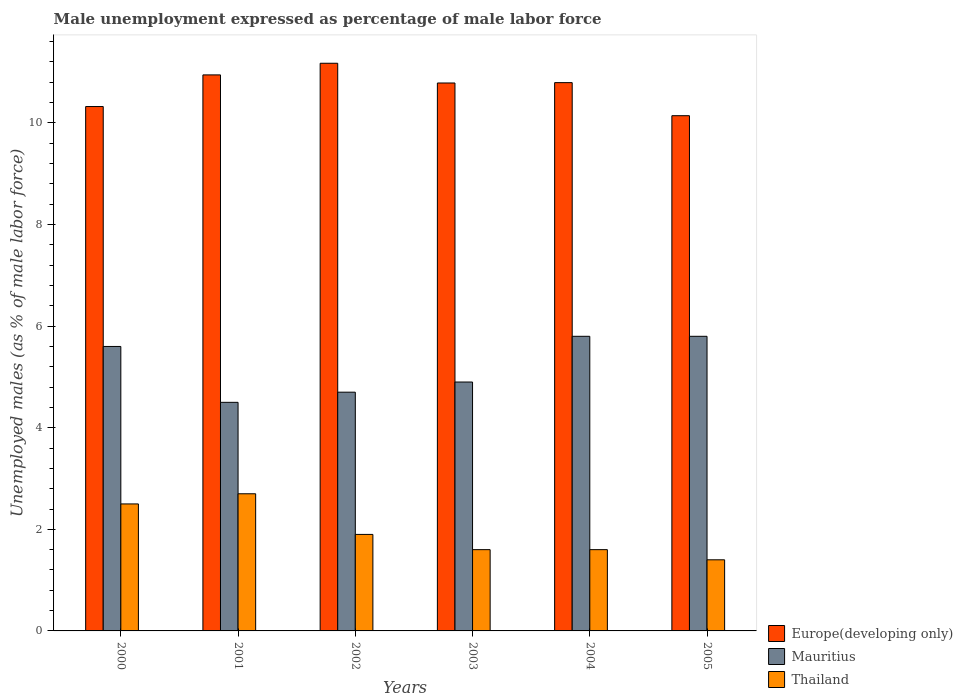Are the number of bars per tick equal to the number of legend labels?
Your response must be concise. Yes. How many bars are there on the 1st tick from the left?
Make the answer very short. 3. What is the label of the 4th group of bars from the left?
Make the answer very short. 2003. In how many cases, is the number of bars for a given year not equal to the number of legend labels?
Provide a succinct answer. 0. What is the unemployment in males in in Thailand in 2003?
Your answer should be very brief. 1.6. Across all years, what is the maximum unemployment in males in in Thailand?
Offer a terse response. 2.7. Across all years, what is the minimum unemployment in males in in Mauritius?
Give a very brief answer. 4.5. In which year was the unemployment in males in in Mauritius minimum?
Your answer should be very brief. 2001. What is the total unemployment in males in in Europe(developing only) in the graph?
Provide a succinct answer. 64.17. What is the difference between the unemployment in males in in Thailand in 2003 and that in 2005?
Offer a very short reply. 0.2. What is the difference between the unemployment in males in in Mauritius in 2003 and the unemployment in males in in Thailand in 2001?
Your answer should be very brief. 2.2. What is the average unemployment in males in in Europe(developing only) per year?
Provide a short and direct response. 10.69. In the year 2003, what is the difference between the unemployment in males in in Thailand and unemployment in males in in Europe(developing only)?
Offer a very short reply. -9.19. What is the ratio of the unemployment in males in in Thailand in 2001 to that in 2003?
Provide a short and direct response. 1.69. Is the unemployment in males in in Europe(developing only) in 2000 less than that in 2003?
Offer a very short reply. Yes. What is the difference between the highest and the second highest unemployment in males in in Mauritius?
Offer a terse response. 0. What is the difference between the highest and the lowest unemployment in males in in Thailand?
Provide a short and direct response. 1.3. In how many years, is the unemployment in males in in Europe(developing only) greater than the average unemployment in males in in Europe(developing only) taken over all years?
Offer a terse response. 4. What does the 1st bar from the left in 2001 represents?
Make the answer very short. Europe(developing only). What does the 3rd bar from the right in 2002 represents?
Offer a very short reply. Europe(developing only). Does the graph contain grids?
Offer a terse response. No. How are the legend labels stacked?
Provide a short and direct response. Vertical. What is the title of the graph?
Keep it short and to the point. Male unemployment expressed as percentage of male labor force. Does "Arab World" appear as one of the legend labels in the graph?
Your response must be concise. No. What is the label or title of the Y-axis?
Your answer should be very brief. Unemployed males (as % of male labor force). What is the Unemployed males (as % of male labor force) of Europe(developing only) in 2000?
Offer a very short reply. 10.32. What is the Unemployed males (as % of male labor force) in Mauritius in 2000?
Make the answer very short. 5.6. What is the Unemployed males (as % of male labor force) of Thailand in 2000?
Your response must be concise. 2.5. What is the Unemployed males (as % of male labor force) of Europe(developing only) in 2001?
Provide a succinct answer. 10.95. What is the Unemployed males (as % of male labor force) in Thailand in 2001?
Offer a very short reply. 2.7. What is the Unemployed males (as % of male labor force) of Europe(developing only) in 2002?
Your response must be concise. 11.18. What is the Unemployed males (as % of male labor force) of Mauritius in 2002?
Make the answer very short. 4.7. What is the Unemployed males (as % of male labor force) of Thailand in 2002?
Your answer should be compact. 1.9. What is the Unemployed males (as % of male labor force) of Europe(developing only) in 2003?
Your answer should be compact. 10.79. What is the Unemployed males (as % of male labor force) in Mauritius in 2003?
Your answer should be compact. 4.9. What is the Unemployed males (as % of male labor force) in Thailand in 2003?
Provide a short and direct response. 1.6. What is the Unemployed males (as % of male labor force) in Europe(developing only) in 2004?
Provide a short and direct response. 10.79. What is the Unemployed males (as % of male labor force) in Mauritius in 2004?
Keep it short and to the point. 5.8. What is the Unemployed males (as % of male labor force) in Thailand in 2004?
Offer a terse response. 1.6. What is the Unemployed males (as % of male labor force) in Europe(developing only) in 2005?
Provide a short and direct response. 10.14. What is the Unemployed males (as % of male labor force) in Mauritius in 2005?
Make the answer very short. 5.8. What is the Unemployed males (as % of male labor force) in Thailand in 2005?
Ensure brevity in your answer.  1.4. Across all years, what is the maximum Unemployed males (as % of male labor force) of Europe(developing only)?
Give a very brief answer. 11.18. Across all years, what is the maximum Unemployed males (as % of male labor force) of Mauritius?
Your response must be concise. 5.8. Across all years, what is the maximum Unemployed males (as % of male labor force) of Thailand?
Your answer should be very brief. 2.7. Across all years, what is the minimum Unemployed males (as % of male labor force) in Europe(developing only)?
Give a very brief answer. 10.14. Across all years, what is the minimum Unemployed males (as % of male labor force) in Mauritius?
Provide a succinct answer. 4.5. Across all years, what is the minimum Unemployed males (as % of male labor force) in Thailand?
Your response must be concise. 1.4. What is the total Unemployed males (as % of male labor force) in Europe(developing only) in the graph?
Give a very brief answer. 64.17. What is the total Unemployed males (as % of male labor force) in Mauritius in the graph?
Give a very brief answer. 31.3. What is the total Unemployed males (as % of male labor force) in Thailand in the graph?
Offer a terse response. 11.7. What is the difference between the Unemployed males (as % of male labor force) in Europe(developing only) in 2000 and that in 2001?
Offer a very short reply. -0.62. What is the difference between the Unemployed males (as % of male labor force) of Thailand in 2000 and that in 2001?
Your response must be concise. -0.2. What is the difference between the Unemployed males (as % of male labor force) in Europe(developing only) in 2000 and that in 2002?
Ensure brevity in your answer.  -0.85. What is the difference between the Unemployed males (as % of male labor force) in Mauritius in 2000 and that in 2002?
Your answer should be very brief. 0.9. What is the difference between the Unemployed males (as % of male labor force) in Thailand in 2000 and that in 2002?
Provide a succinct answer. 0.6. What is the difference between the Unemployed males (as % of male labor force) of Europe(developing only) in 2000 and that in 2003?
Provide a short and direct response. -0.46. What is the difference between the Unemployed males (as % of male labor force) of Mauritius in 2000 and that in 2003?
Your answer should be compact. 0.7. What is the difference between the Unemployed males (as % of male labor force) in Europe(developing only) in 2000 and that in 2004?
Keep it short and to the point. -0.47. What is the difference between the Unemployed males (as % of male labor force) of Mauritius in 2000 and that in 2004?
Make the answer very short. -0.2. What is the difference between the Unemployed males (as % of male labor force) in Europe(developing only) in 2000 and that in 2005?
Your answer should be very brief. 0.18. What is the difference between the Unemployed males (as % of male labor force) of Thailand in 2000 and that in 2005?
Offer a very short reply. 1.1. What is the difference between the Unemployed males (as % of male labor force) in Europe(developing only) in 2001 and that in 2002?
Give a very brief answer. -0.23. What is the difference between the Unemployed males (as % of male labor force) of Thailand in 2001 and that in 2002?
Offer a terse response. 0.8. What is the difference between the Unemployed males (as % of male labor force) of Europe(developing only) in 2001 and that in 2003?
Your answer should be compact. 0.16. What is the difference between the Unemployed males (as % of male labor force) of Thailand in 2001 and that in 2003?
Give a very brief answer. 1.1. What is the difference between the Unemployed males (as % of male labor force) in Europe(developing only) in 2001 and that in 2004?
Your response must be concise. 0.15. What is the difference between the Unemployed males (as % of male labor force) of Europe(developing only) in 2001 and that in 2005?
Provide a short and direct response. 0.8. What is the difference between the Unemployed males (as % of male labor force) of Thailand in 2001 and that in 2005?
Your answer should be very brief. 1.3. What is the difference between the Unemployed males (as % of male labor force) in Europe(developing only) in 2002 and that in 2003?
Your response must be concise. 0.39. What is the difference between the Unemployed males (as % of male labor force) of Mauritius in 2002 and that in 2003?
Give a very brief answer. -0.2. What is the difference between the Unemployed males (as % of male labor force) of Thailand in 2002 and that in 2003?
Give a very brief answer. 0.3. What is the difference between the Unemployed males (as % of male labor force) of Europe(developing only) in 2002 and that in 2004?
Your answer should be compact. 0.38. What is the difference between the Unemployed males (as % of male labor force) in Mauritius in 2002 and that in 2004?
Offer a very short reply. -1.1. What is the difference between the Unemployed males (as % of male labor force) of Thailand in 2002 and that in 2004?
Your answer should be very brief. 0.3. What is the difference between the Unemployed males (as % of male labor force) of Europe(developing only) in 2002 and that in 2005?
Ensure brevity in your answer.  1.03. What is the difference between the Unemployed males (as % of male labor force) of Thailand in 2002 and that in 2005?
Your answer should be very brief. 0.5. What is the difference between the Unemployed males (as % of male labor force) of Europe(developing only) in 2003 and that in 2004?
Your answer should be very brief. -0.01. What is the difference between the Unemployed males (as % of male labor force) in Thailand in 2003 and that in 2004?
Your answer should be compact. 0. What is the difference between the Unemployed males (as % of male labor force) of Europe(developing only) in 2003 and that in 2005?
Give a very brief answer. 0.64. What is the difference between the Unemployed males (as % of male labor force) in Europe(developing only) in 2004 and that in 2005?
Provide a succinct answer. 0.65. What is the difference between the Unemployed males (as % of male labor force) of Mauritius in 2004 and that in 2005?
Provide a succinct answer. 0. What is the difference between the Unemployed males (as % of male labor force) in Thailand in 2004 and that in 2005?
Provide a succinct answer. 0.2. What is the difference between the Unemployed males (as % of male labor force) of Europe(developing only) in 2000 and the Unemployed males (as % of male labor force) of Mauritius in 2001?
Offer a terse response. 5.82. What is the difference between the Unemployed males (as % of male labor force) of Europe(developing only) in 2000 and the Unemployed males (as % of male labor force) of Thailand in 2001?
Give a very brief answer. 7.62. What is the difference between the Unemployed males (as % of male labor force) in Mauritius in 2000 and the Unemployed males (as % of male labor force) in Thailand in 2001?
Keep it short and to the point. 2.9. What is the difference between the Unemployed males (as % of male labor force) in Europe(developing only) in 2000 and the Unemployed males (as % of male labor force) in Mauritius in 2002?
Keep it short and to the point. 5.62. What is the difference between the Unemployed males (as % of male labor force) of Europe(developing only) in 2000 and the Unemployed males (as % of male labor force) of Thailand in 2002?
Give a very brief answer. 8.42. What is the difference between the Unemployed males (as % of male labor force) of Europe(developing only) in 2000 and the Unemployed males (as % of male labor force) of Mauritius in 2003?
Provide a succinct answer. 5.42. What is the difference between the Unemployed males (as % of male labor force) of Europe(developing only) in 2000 and the Unemployed males (as % of male labor force) of Thailand in 2003?
Ensure brevity in your answer.  8.72. What is the difference between the Unemployed males (as % of male labor force) of Mauritius in 2000 and the Unemployed males (as % of male labor force) of Thailand in 2003?
Your answer should be very brief. 4. What is the difference between the Unemployed males (as % of male labor force) in Europe(developing only) in 2000 and the Unemployed males (as % of male labor force) in Mauritius in 2004?
Make the answer very short. 4.52. What is the difference between the Unemployed males (as % of male labor force) of Europe(developing only) in 2000 and the Unemployed males (as % of male labor force) of Thailand in 2004?
Your response must be concise. 8.72. What is the difference between the Unemployed males (as % of male labor force) of Europe(developing only) in 2000 and the Unemployed males (as % of male labor force) of Mauritius in 2005?
Provide a succinct answer. 4.52. What is the difference between the Unemployed males (as % of male labor force) of Europe(developing only) in 2000 and the Unemployed males (as % of male labor force) of Thailand in 2005?
Keep it short and to the point. 8.92. What is the difference between the Unemployed males (as % of male labor force) in Europe(developing only) in 2001 and the Unemployed males (as % of male labor force) in Mauritius in 2002?
Provide a short and direct response. 6.25. What is the difference between the Unemployed males (as % of male labor force) in Europe(developing only) in 2001 and the Unemployed males (as % of male labor force) in Thailand in 2002?
Provide a succinct answer. 9.05. What is the difference between the Unemployed males (as % of male labor force) of Mauritius in 2001 and the Unemployed males (as % of male labor force) of Thailand in 2002?
Offer a terse response. 2.6. What is the difference between the Unemployed males (as % of male labor force) in Europe(developing only) in 2001 and the Unemployed males (as % of male labor force) in Mauritius in 2003?
Provide a succinct answer. 6.05. What is the difference between the Unemployed males (as % of male labor force) in Europe(developing only) in 2001 and the Unemployed males (as % of male labor force) in Thailand in 2003?
Ensure brevity in your answer.  9.35. What is the difference between the Unemployed males (as % of male labor force) in Mauritius in 2001 and the Unemployed males (as % of male labor force) in Thailand in 2003?
Ensure brevity in your answer.  2.9. What is the difference between the Unemployed males (as % of male labor force) of Europe(developing only) in 2001 and the Unemployed males (as % of male labor force) of Mauritius in 2004?
Offer a terse response. 5.15. What is the difference between the Unemployed males (as % of male labor force) of Europe(developing only) in 2001 and the Unemployed males (as % of male labor force) of Thailand in 2004?
Your answer should be compact. 9.35. What is the difference between the Unemployed males (as % of male labor force) in Mauritius in 2001 and the Unemployed males (as % of male labor force) in Thailand in 2004?
Keep it short and to the point. 2.9. What is the difference between the Unemployed males (as % of male labor force) of Europe(developing only) in 2001 and the Unemployed males (as % of male labor force) of Mauritius in 2005?
Offer a very short reply. 5.15. What is the difference between the Unemployed males (as % of male labor force) of Europe(developing only) in 2001 and the Unemployed males (as % of male labor force) of Thailand in 2005?
Your response must be concise. 9.55. What is the difference between the Unemployed males (as % of male labor force) in Mauritius in 2001 and the Unemployed males (as % of male labor force) in Thailand in 2005?
Provide a succinct answer. 3.1. What is the difference between the Unemployed males (as % of male labor force) of Europe(developing only) in 2002 and the Unemployed males (as % of male labor force) of Mauritius in 2003?
Provide a succinct answer. 6.28. What is the difference between the Unemployed males (as % of male labor force) of Europe(developing only) in 2002 and the Unemployed males (as % of male labor force) of Thailand in 2003?
Keep it short and to the point. 9.58. What is the difference between the Unemployed males (as % of male labor force) in Mauritius in 2002 and the Unemployed males (as % of male labor force) in Thailand in 2003?
Your response must be concise. 3.1. What is the difference between the Unemployed males (as % of male labor force) of Europe(developing only) in 2002 and the Unemployed males (as % of male labor force) of Mauritius in 2004?
Offer a very short reply. 5.38. What is the difference between the Unemployed males (as % of male labor force) of Europe(developing only) in 2002 and the Unemployed males (as % of male labor force) of Thailand in 2004?
Offer a very short reply. 9.58. What is the difference between the Unemployed males (as % of male labor force) of Mauritius in 2002 and the Unemployed males (as % of male labor force) of Thailand in 2004?
Make the answer very short. 3.1. What is the difference between the Unemployed males (as % of male labor force) in Europe(developing only) in 2002 and the Unemployed males (as % of male labor force) in Mauritius in 2005?
Your answer should be compact. 5.38. What is the difference between the Unemployed males (as % of male labor force) of Europe(developing only) in 2002 and the Unemployed males (as % of male labor force) of Thailand in 2005?
Provide a succinct answer. 9.78. What is the difference between the Unemployed males (as % of male labor force) in Mauritius in 2002 and the Unemployed males (as % of male labor force) in Thailand in 2005?
Your answer should be very brief. 3.3. What is the difference between the Unemployed males (as % of male labor force) in Europe(developing only) in 2003 and the Unemployed males (as % of male labor force) in Mauritius in 2004?
Provide a succinct answer. 4.99. What is the difference between the Unemployed males (as % of male labor force) of Europe(developing only) in 2003 and the Unemployed males (as % of male labor force) of Thailand in 2004?
Your response must be concise. 9.19. What is the difference between the Unemployed males (as % of male labor force) in Mauritius in 2003 and the Unemployed males (as % of male labor force) in Thailand in 2004?
Your answer should be compact. 3.3. What is the difference between the Unemployed males (as % of male labor force) in Europe(developing only) in 2003 and the Unemployed males (as % of male labor force) in Mauritius in 2005?
Your response must be concise. 4.99. What is the difference between the Unemployed males (as % of male labor force) in Europe(developing only) in 2003 and the Unemployed males (as % of male labor force) in Thailand in 2005?
Keep it short and to the point. 9.39. What is the difference between the Unemployed males (as % of male labor force) of Mauritius in 2003 and the Unemployed males (as % of male labor force) of Thailand in 2005?
Provide a short and direct response. 3.5. What is the difference between the Unemployed males (as % of male labor force) in Europe(developing only) in 2004 and the Unemployed males (as % of male labor force) in Mauritius in 2005?
Your response must be concise. 4.99. What is the difference between the Unemployed males (as % of male labor force) in Europe(developing only) in 2004 and the Unemployed males (as % of male labor force) in Thailand in 2005?
Make the answer very short. 9.39. What is the difference between the Unemployed males (as % of male labor force) in Mauritius in 2004 and the Unemployed males (as % of male labor force) in Thailand in 2005?
Provide a short and direct response. 4.4. What is the average Unemployed males (as % of male labor force) of Europe(developing only) per year?
Ensure brevity in your answer.  10.69. What is the average Unemployed males (as % of male labor force) of Mauritius per year?
Ensure brevity in your answer.  5.22. What is the average Unemployed males (as % of male labor force) in Thailand per year?
Provide a short and direct response. 1.95. In the year 2000, what is the difference between the Unemployed males (as % of male labor force) of Europe(developing only) and Unemployed males (as % of male labor force) of Mauritius?
Provide a succinct answer. 4.72. In the year 2000, what is the difference between the Unemployed males (as % of male labor force) in Europe(developing only) and Unemployed males (as % of male labor force) in Thailand?
Ensure brevity in your answer.  7.82. In the year 2001, what is the difference between the Unemployed males (as % of male labor force) of Europe(developing only) and Unemployed males (as % of male labor force) of Mauritius?
Give a very brief answer. 6.45. In the year 2001, what is the difference between the Unemployed males (as % of male labor force) of Europe(developing only) and Unemployed males (as % of male labor force) of Thailand?
Offer a very short reply. 8.25. In the year 2001, what is the difference between the Unemployed males (as % of male labor force) of Mauritius and Unemployed males (as % of male labor force) of Thailand?
Your answer should be compact. 1.8. In the year 2002, what is the difference between the Unemployed males (as % of male labor force) of Europe(developing only) and Unemployed males (as % of male labor force) of Mauritius?
Give a very brief answer. 6.48. In the year 2002, what is the difference between the Unemployed males (as % of male labor force) in Europe(developing only) and Unemployed males (as % of male labor force) in Thailand?
Offer a terse response. 9.28. In the year 2002, what is the difference between the Unemployed males (as % of male labor force) in Mauritius and Unemployed males (as % of male labor force) in Thailand?
Offer a terse response. 2.8. In the year 2003, what is the difference between the Unemployed males (as % of male labor force) of Europe(developing only) and Unemployed males (as % of male labor force) of Mauritius?
Your response must be concise. 5.89. In the year 2003, what is the difference between the Unemployed males (as % of male labor force) in Europe(developing only) and Unemployed males (as % of male labor force) in Thailand?
Keep it short and to the point. 9.19. In the year 2003, what is the difference between the Unemployed males (as % of male labor force) of Mauritius and Unemployed males (as % of male labor force) of Thailand?
Your answer should be very brief. 3.3. In the year 2004, what is the difference between the Unemployed males (as % of male labor force) of Europe(developing only) and Unemployed males (as % of male labor force) of Mauritius?
Ensure brevity in your answer.  4.99. In the year 2004, what is the difference between the Unemployed males (as % of male labor force) of Europe(developing only) and Unemployed males (as % of male labor force) of Thailand?
Ensure brevity in your answer.  9.19. In the year 2005, what is the difference between the Unemployed males (as % of male labor force) of Europe(developing only) and Unemployed males (as % of male labor force) of Mauritius?
Offer a very short reply. 4.34. In the year 2005, what is the difference between the Unemployed males (as % of male labor force) in Europe(developing only) and Unemployed males (as % of male labor force) in Thailand?
Provide a short and direct response. 8.74. In the year 2005, what is the difference between the Unemployed males (as % of male labor force) of Mauritius and Unemployed males (as % of male labor force) of Thailand?
Provide a short and direct response. 4.4. What is the ratio of the Unemployed males (as % of male labor force) of Europe(developing only) in 2000 to that in 2001?
Make the answer very short. 0.94. What is the ratio of the Unemployed males (as % of male labor force) of Mauritius in 2000 to that in 2001?
Provide a succinct answer. 1.24. What is the ratio of the Unemployed males (as % of male labor force) in Thailand in 2000 to that in 2001?
Keep it short and to the point. 0.93. What is the ratio of the Unemployed males (as % of male labor force) of Europe(developing only) in 2000 to that in 2002?
Your response must be concise. 0.92. What is the ratio of the Unemployed males (as % of male labor force) of Mauritius in 2000 to that in 2002?
Provide a succinct answer. 1.19. What is the ratio of the Unemployed males (as % of male labor force) in Thailand in 2000 to that in 2002?
Provide a succinct answer. 1.32. What is the ratio of the Unemployed males (as % of male labor force) in Europe(developing only) in 2000 to that in 2003?
Offer a terse response. 0.96. What is the ratio of the Unemployed males (as % of male labor force) of Mauritius in 2000 to that in 2003?
Give a very brief answer. 1.14. What is the ratio of the Unemployed males (as % of male labor force) in Thailand in 2000 to that in 2003?
Offer a very short reply. 1.56. What is the ratio of the Unemployed males (as % of male labor force) of Europe(developing only) in 2000 to that in 2004?
Offer a terse response. 0.96. What is the ratio of the Unemployed males (as % of male labor force) of Mauritius in 2000 to that in 2004?
Provide a succinct answer. 0.97. What is the ratio of the Unemployed males (as % of male labor force) in Thailand in 2000 to that in 2004?
Give a very brief answer. 1.56. What is the ratio of the Unemployed males (as % of male labor force) in Europe(developing only) in 2000 to that in 2005?
Provide a short and direct response. 1.02. What is the ratio of the Unemployed males (as % of male labor force) in Mauritius in 2000 to that in 2005?
Provide a short and direct response. 0.97. What is the ratio of the Unemployed males (as % of male labor force) of Thailand in 2000 to that in 2005?
Make the answer very short. 1.79. What is the ratio of the Unemployed males (as % of male labor force) in Europe(developing only) in 2001 to that in 2002?
Offer a very short reply. 0.98. What is the ratio of the Unemployed males (as % of male labor force) of Mauritius in 2001 to that in 2002?
Provide a succinct answer. 0.96. What is the ratio of the Unemployed males (as % of male labor force) of Thailand in 2001 to that in 2002?
Your answer should be compact. 1.42. What is the ratio of the Unemployed males (as % of male labor force) of Europe(developing only) in 2001 to that in 2003?
Your response must be concise. 1.01. What is the ratio of the Unemployed males (as % of male labor force) of Mauritius in 2001 to that in 2003?
Ensure brevity in your answer.  0.92. What is the ratio of the Unemployed males (as % of male labor force) in Thailand in 2001 to that in 2003?
Your answer should be compact. 1.69. What is the ratio of the Unemployed males (as % of male labor force) in Europe(developing only) in 2001 to that in 2004?
Offer a terse response. 1.01. What is the ratio of the Unemployed males (as % of male labor force) in Mauritius in 2001 to that in 2004?
Your response must be concise. 0.78. What is the ratio of the Unemployed males (as % of male labor force) of Thailand in 2001 to that in 2004?
Your answer should be compact. 1.69. What is the ratio of the Unemployed males (as % of male labor force) in Europe(developing only) in 2001 to that in 2005?
Give a very brief answer. 1.08. What is the ratio of the Unemployed males (as % of male labor force) of Mauritius in 2001 to that in 2005?
Give a very brief answer. 0.78. What is the ratio of the Unemployed males (as % of male labor force) of Thailand in 2001 to that in 2005?
Make the answer very short. 1.93. What is the ratio of the Unemployed males (as % of male labor force) of Europe(developing only) in 2002 to that in 2003?
Provide a succinct answer. 1.04. What is the ratio of the Unemployed males (as % of male labor force) in Mauritius in 2002 to that in 2003?
Offer a terse response. 0.96. What is the ratio of the Unemployed males (as % of male labor force) in Thailand in 2002 to that in 2003?
Provide a short and direct response. 1.19. What is the ratio of the Unemployed males (as % of male labor force) of Europe(developing only) in 2002 to that in 2004?
Keep it short and to the point. 1.04. What is the ratio of the Unemployed males (as % of male labor force) in Mauritius in 2002 to that in 2004?
Make the answer very short. 0.81. What is the ratio of the Unemployed males (as % of male labor force) in Thailand in 2002 to that in 2004?
Make the answer very short. 1.19. What is the ratio of the Unemployed males (as % of male labor force) in Europe(developing only) in 2002 to that in 2005?
Offer a very short reply. 1.1. What is the ratio of the Unemployed males (as % of male labor force) of Mauritius in 2002 to that in 2005?
Provide a short and direct response. 0.81. What is the ratio of the Unemployed males (as % of male labor force) of Thailand in 2002 to that in 2005?
Your response must be concise. 1.36. What is the ratio of the Unemployed males (as % of male labor force) of Mauritius in 2003 to that in 2004?
Make the answer very short. 0.84. What is the ratio of the Unemployed males (as % of male labor force) in Europe(developing only) in 2003 to that in 2005?
Your response must be concise. 1.06. What is the ratio of the Unemployed males (as % of male labor force) of Mauritius in 2003 to that in 2005?
Ensure brevity in your answer.  0.84. What is the ratio of the Unemployed males (as % of male labor force) in Europe(developing only) in 2004 to that in 2005?
Your answer should be compact. 1.06. What is the ratio of the Unemployed males (as % of male labor force) in Thailand in 2004 to that in 2005?
Offer a terse response. 1.14. What is the difference between the highest and the second highest Unemployed males (as % of male labor force) of Europe(developing only)?
Keep it short and to the point. 0.23. What is the difference between the highest and the lowest Unemployed males (as % of male labor force) of Europe(developing only)?
Your answer should be compact. 1.03. What is the difference between the highest and the lowest Unemployed males (as % of male labor force) in Thailand?
Offer a very short reply. 1.3. 